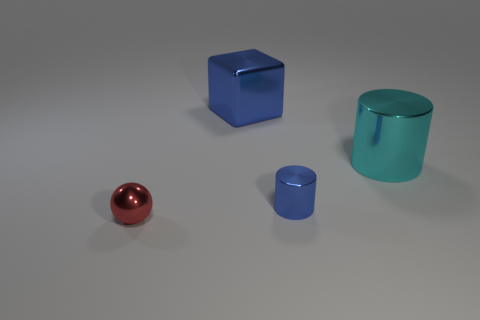Subtract all blue cylinders. How many cylinders are left? 1 Subtract all spheres. How many objects are left? 3 Add 1 tiny blue objects. How many objects exist? 5 Add 4 metallic things. How many metallic things are left? 8 Add 1 purple cylinders. How many purple cylinders exist? 1 Subtract 0 brown spheres. How many objects are left? 4 Subtract 1 spheres. How many spheres are left? 0 Subtract all purple cubes. Subtract all yellow balls. How many cubes are left? 1 Subtract all red spheres. How many red cubes are left? 0 Subtract all large red metallic cubes. Subtract all metallic blocks. How many objects are left? 3 